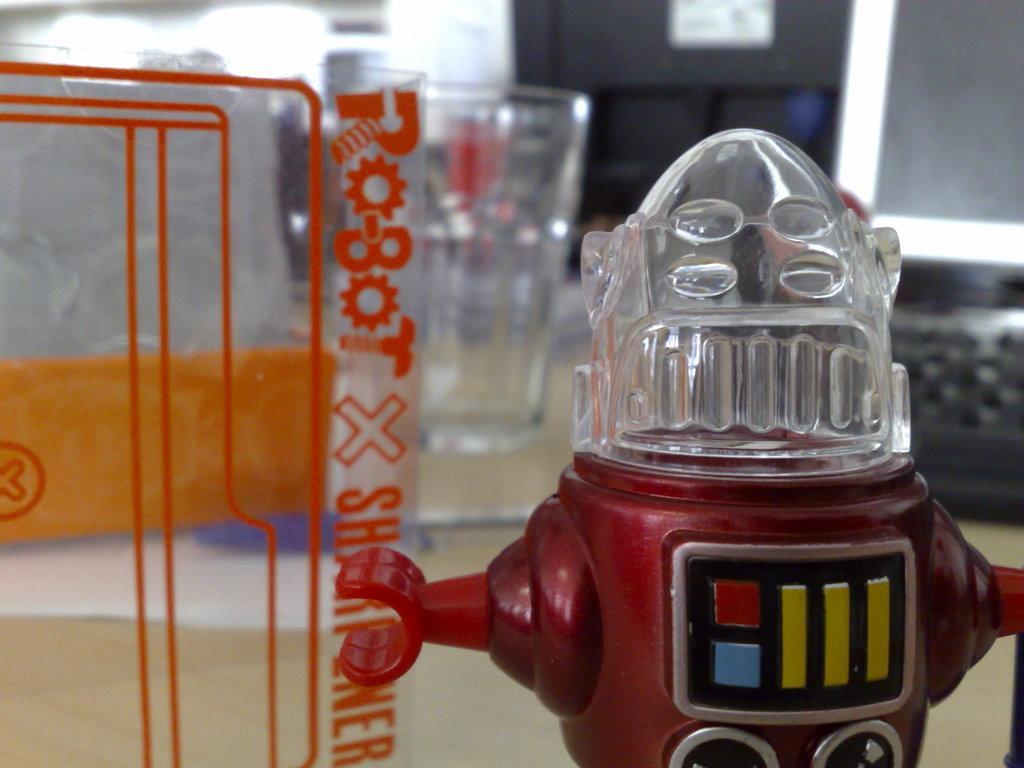<image>
Describe the image concisely. A robot with a see through glass head standing on a floor pointing to robot x. 